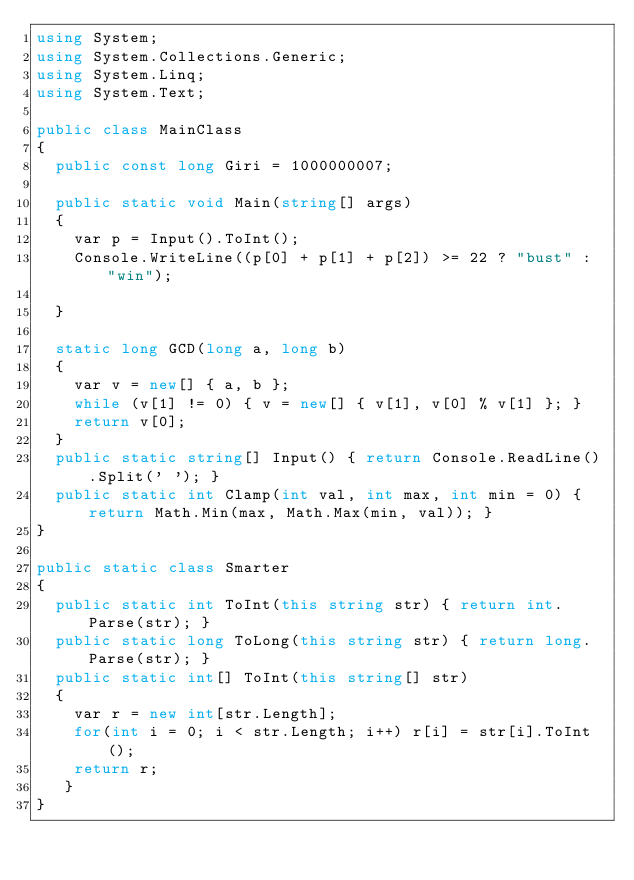Convert code to text. <code><loc_0><loc_0><loc_500><loc_500><_C#_>using System;
using System.Collections.Generic;
using System.Linq;
using System.Text;

public class MainClass
{
	public const long Giri = 1000000007;

	public static void Main(string[] args)
	{
		var p = Input().ToInt();
		Console.WriteLine((p[0] + p[1] + p[2]) >= 22 ? "bust" : "win");
		
	}

	static long GCD(long a, long b)
	{
		var v = new[] { a, b };
		while (v[1] != 0) { v = new[] { v[1], v[0] % v[1] }; }
		return v[0];
	}
	public static string[] Input() { return Console.ReadLine().Split(' '); }
	public static int Clamp(int val, int max, int min = 0) { return Math.Min(max, Math.Max(min, val)); }
}

public static class Smarter
{
	public static int ToInt(this string str) { return int.Parse(str); }
	public static long ToLong(this string str) { return long.Parse(str); }
	public static int[] ToInt(this string[] str)
	{
		var r = new int[str.Length];
		for(int i = 0; i < str.Length; i++) r[i] = str[i].ToInt();
		return r;
	 }
}
</code> 